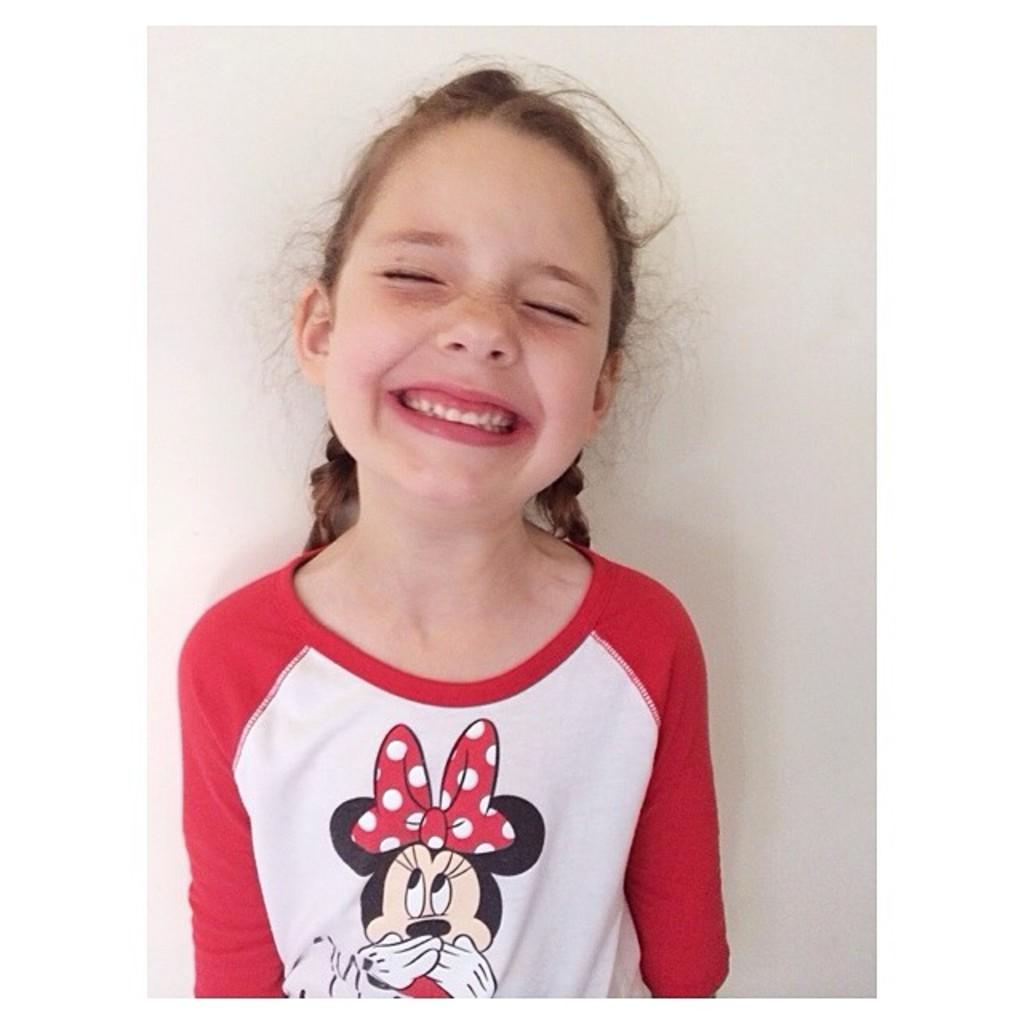Who is the main subject in the picture? There is a girl in the picture. What expression does the girl have? The girl is smiling. What color is the background of the image? The background of the image is white. What tools does the carpenter use in the image? There is no carpenter present in the image, so no tools can be observed. How does the girl's stomach look in the image? The provided facts do not mention the girl's stomach, so it cannot be described based on the information given. 